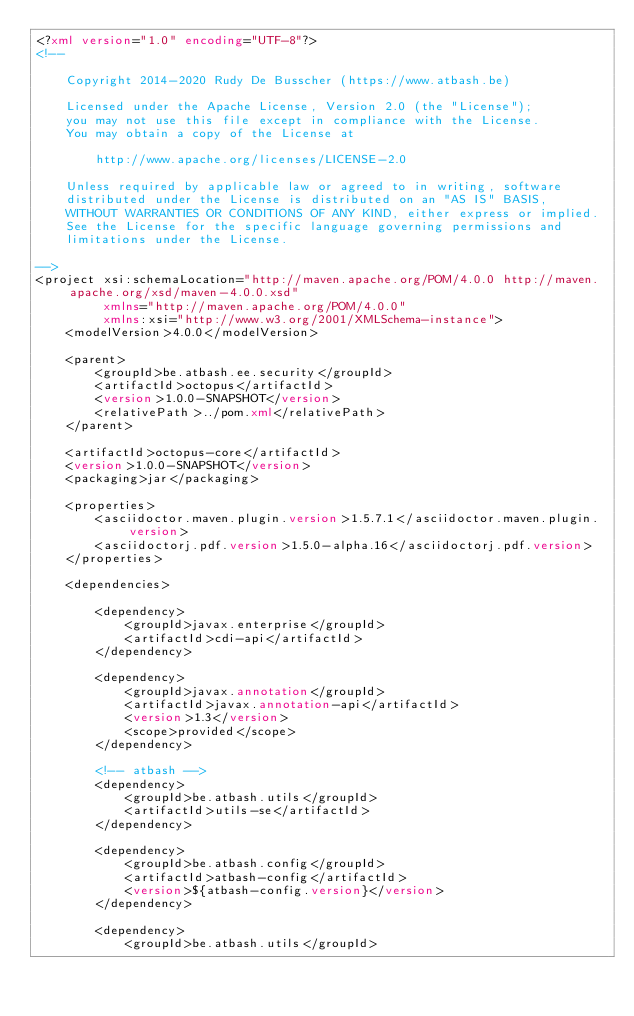<code> <loc_0><loc_0><loc_500><loc_500><_XML_><?xml version="1.0" encoding="UTF-8"?>
<!--

    Copyright 2014-2020 Rudy De Busscher (https://www.atbash.be)

    Licensed under the Apache License, Version 2.0 (the "License");
    you may not use this file except in compliance with the License.
    You may obtain a copy of the License at

        http://www.apache.org/licenses/LICENSE-2.0

    Unless required by applicable law or agreed to in writing, software
    distributed under the License is distributed on an "AS IS" BASIS,
    WITHOUT WARRANTIES OR CONDITIONS OF ANY KIND, either express or implied.
    See the License for the specific language governing permissions and
    limitations under the License.

-->
<project xsi:schemaLocation="http://maven.apache.org/POM/4.0.0 http://maven.apache.org/xsd/maven-4.0.0.xsd"
         xmlns="http://maven.apache.org/POM/4.0.0"
         xmlns:xsi="http://www.w3.org/2001/XMLSchema-instance">
    <modelVersion>4.0.0</modelVersion>

    <parent>
        <groupId>be.atbash.ee.security</groupId>
        <artifactId>octopus</artifactId>
        <version>1.0.0-SNAPSHOT</version>
        <relativePath>../pom.xml</relativePath>
    </parent>

    <artifactId>octopus-core</artifactId>
    <version>1.0.0-SNAPSHOT</version>
    <packaging>jar</packaging>

    <properties>
        <asciidoctor.maven.plugin.version>1.5.7.1</asciidoctor.maven.plugin.version>
        <asciidoctorj.pdf.version>1.5.0-alpha.16</asciidoctorj.pdf.version>
    </properties>

    <dependencies>

        <dependency>
            <groupId>javax.enterprise</groupId>
            <artifactId>cdi-api</artifactId>
        </dependency>

        <dependency>
            <groupId>javax.annotation</groupId>
            <artifactId>javax.annotation-api</artifactId>
            <version>1.3</version>
            <scope>provided</scope>
        </dependency>

        <!-- atbash -->
        <dependency>
            <groupId>be.atbash.utils</groupId>
            <artifactId>utils-se</artifactId>
        </dependency>

        <dependency>
            <groupId>be.atbash.config</groupId>
            <artifactId>atbash-config</artifactId>
            <version>${atbash-config.version}</version>
        </dependency>

        <dependency>
            <groupId>be.atbash.utils</groupId></code> 